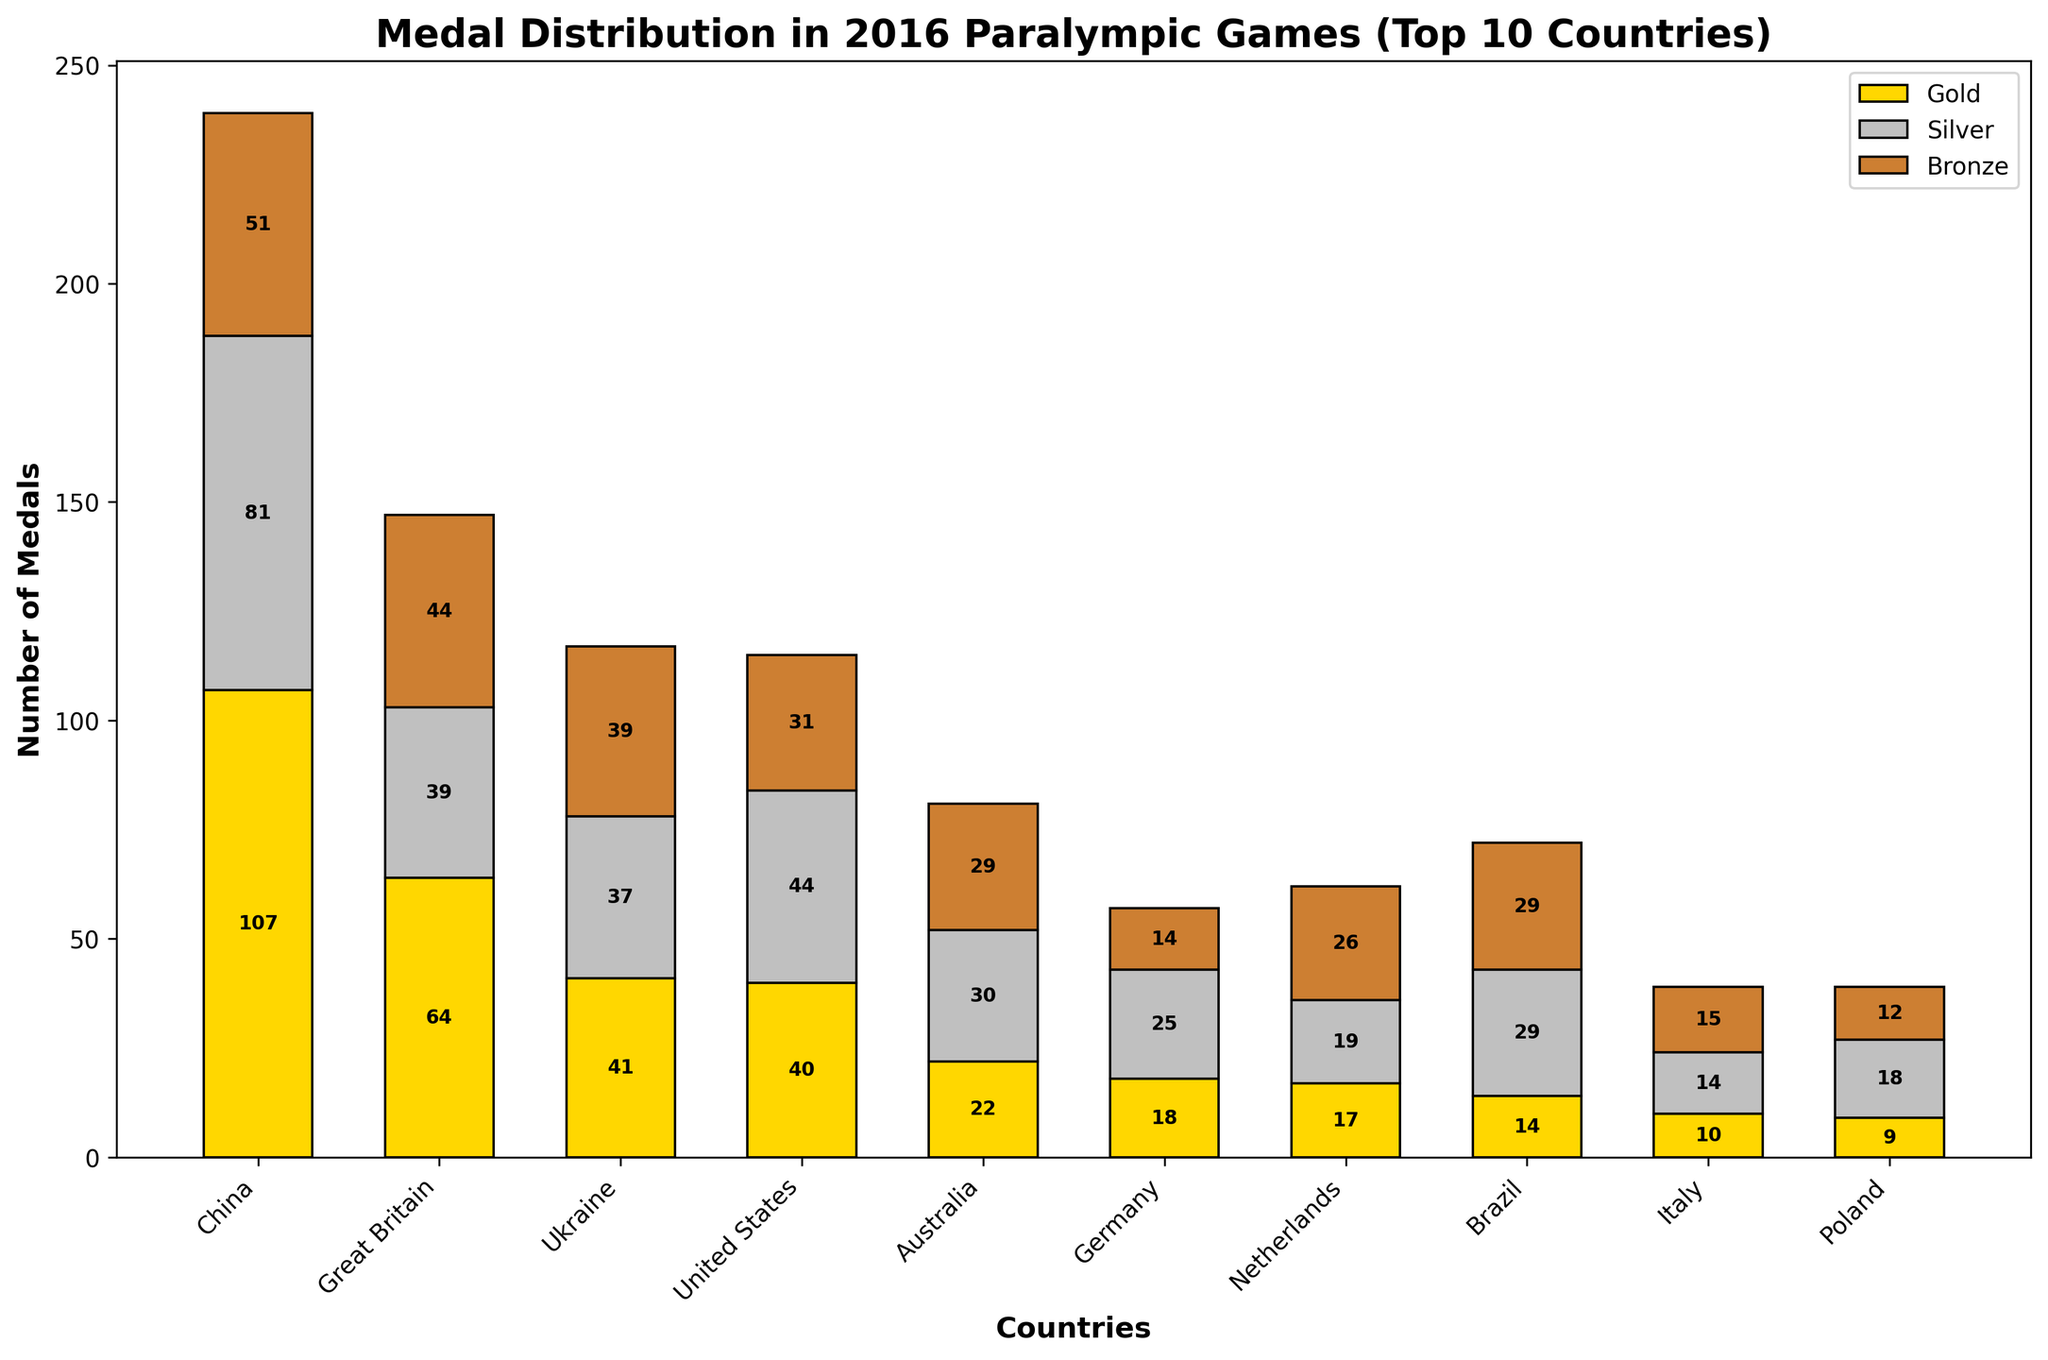Which country won the most medals overall, and how many? The figure shows the total number of medals by country, and the country with the tallest bar is China, indicating it won the most medals. Adding the individual Gold, Silver, and Bronze medals for China gives 239.
Answer: China, 239 How many more Gold medals did China win compared to the United States? From the chart, China has the highest Gold medal count at 107, and the United States has 40. Subtracting the two values: 107 - 40 = 67.
Answer: 67 Which country earned more Silver medals, Brazil or Germany? By comparing the height of the Silver medal sections for Brazil and Germany, we see that Brazil earned 29 Silver medals while Germany earned 25.
Answer: Brazil What is the total number of Bronze medals won by Great Britain and Ukraine combined? From the chart, Great Britain has 44 Bronze medals, and Ukraine has 39. Adding these values together: 44 + 39 = 83.
Answer: 83 Which country has a higher total medal count, Netherlands or Brazil, and by how much? The chart shows that Netherlands has a total of 62 medals, and Brazil has 72. Subtracting these values: 72 - 62 = 10.
Answer: Brazil, 10 What is the predominant color in the bar representing Gold medals? The Gold medal sections are all color-coded in a golden yellow color.
Answer: Gold Which country has the smallest number of total medals among the top 10, and how many? By comparing the heights of the total medal bars, Italy and Poland both show the smallest total bar heights with Italy having 39 and Poland also having 39.
Answer: Italy, 39 (also Poland, 39) What is the combined total number of medals won by the top 3 countries? Adding together the total medals for China (239), Great Britain (147), and Ukraine (117): 239 + 147 + 117 = 503.
Answer: 503 How does the number of Silver medals for Italy compare to that for Poland? Italy has 14 Silver medals, and Poland has 18 Silver medals. Therefore, Poland has more.
Answer: Poland has more Which country is ranked fourth in terms of total medals, and how many medals did they achieve? From the chart, the fourth tallest total medal bar belongs to the United States with 115 medals.
Answer: United States, 115 